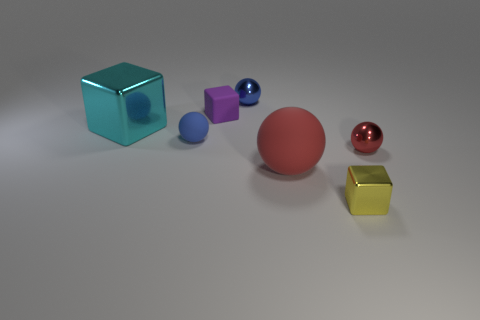What number of metallic spheres are right of the red metal sphere?
Your answer should be compact. 0. There is a ball that is both to the right of the blue shiny object and behind the big matte thing; what is it made of?
Your answer should be compact. Metal. How many tiny things are red balls or cyan shiny objects?
Make the answer very short. 1. The blue matte sphere is what size?
Give a very brief answer. Small. The blue matte object has what shape?
Your response must be concise. Sphere. Is there any other thing that is the same shape as the cyan metal thing?
Make the answer very short. Yes. Are there fewer small spheres that are behind the purple matte object than small red metallic spheres?
Your response must be concise. No. Is the color of the small matte object that is in front of the big block the same as the big metallic object?
Your answer should be compact. No. How many rubber objects are tiny red spheres or red spheres?
Provide a short and direct response. 1. Is there anything else that is the same size as the red metal sphere?
Your answer should be very brief. Yes. 